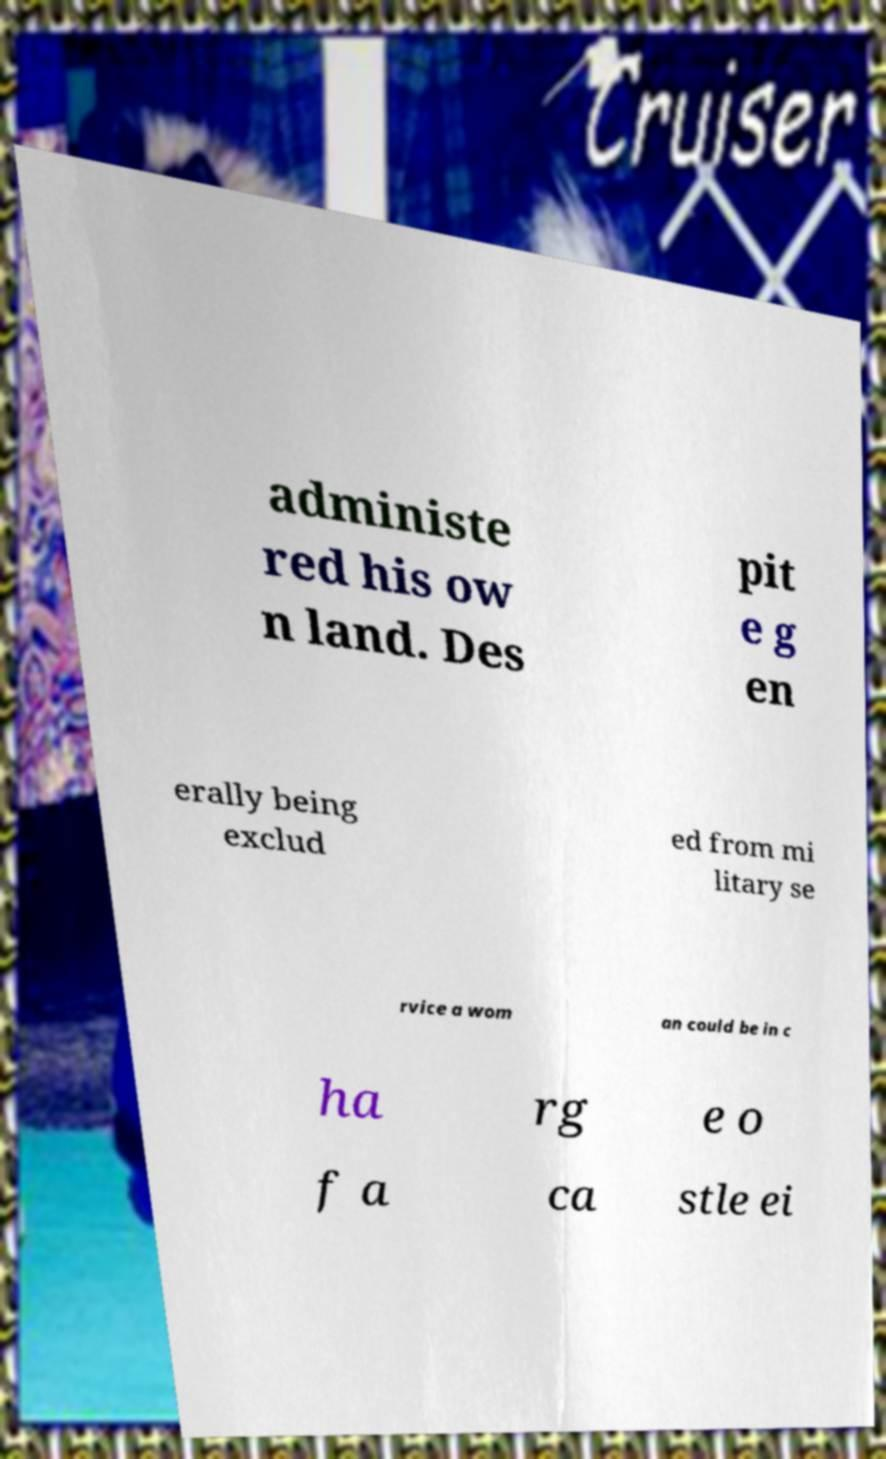Could you assist in decoding the text presented in this image and type it out clearly? administe red his ow n land. Des pit e g en erally being exclud ed from mi litary se rvice a wom an could be in c ha rg e o f a ca stle ei 